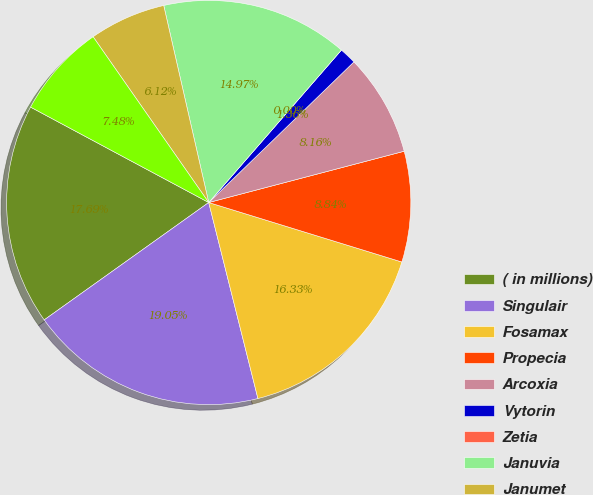Convert chart to OTSL. <chart><loc_0><loc_0><loc_500><loc_500><pie_chart><fcel>( in millions)<fcel>Singulair<fcel>Fosamax<fcel>Propecia<fcel>Arcoxia<fcel>Vytorin<fcel>Zetia<fcel>Januvia<fcel>Janumet<fcel>Isentress<nl><fcel>17.69%<fcel>19.05%<fcel>16.33%<fcel>8.84%<fcel>8.16%<fcel>1.36%<fcel>0.0%<fcel>14.97%<fcel>6.12%<fcel>7.48%<nl></chart> 